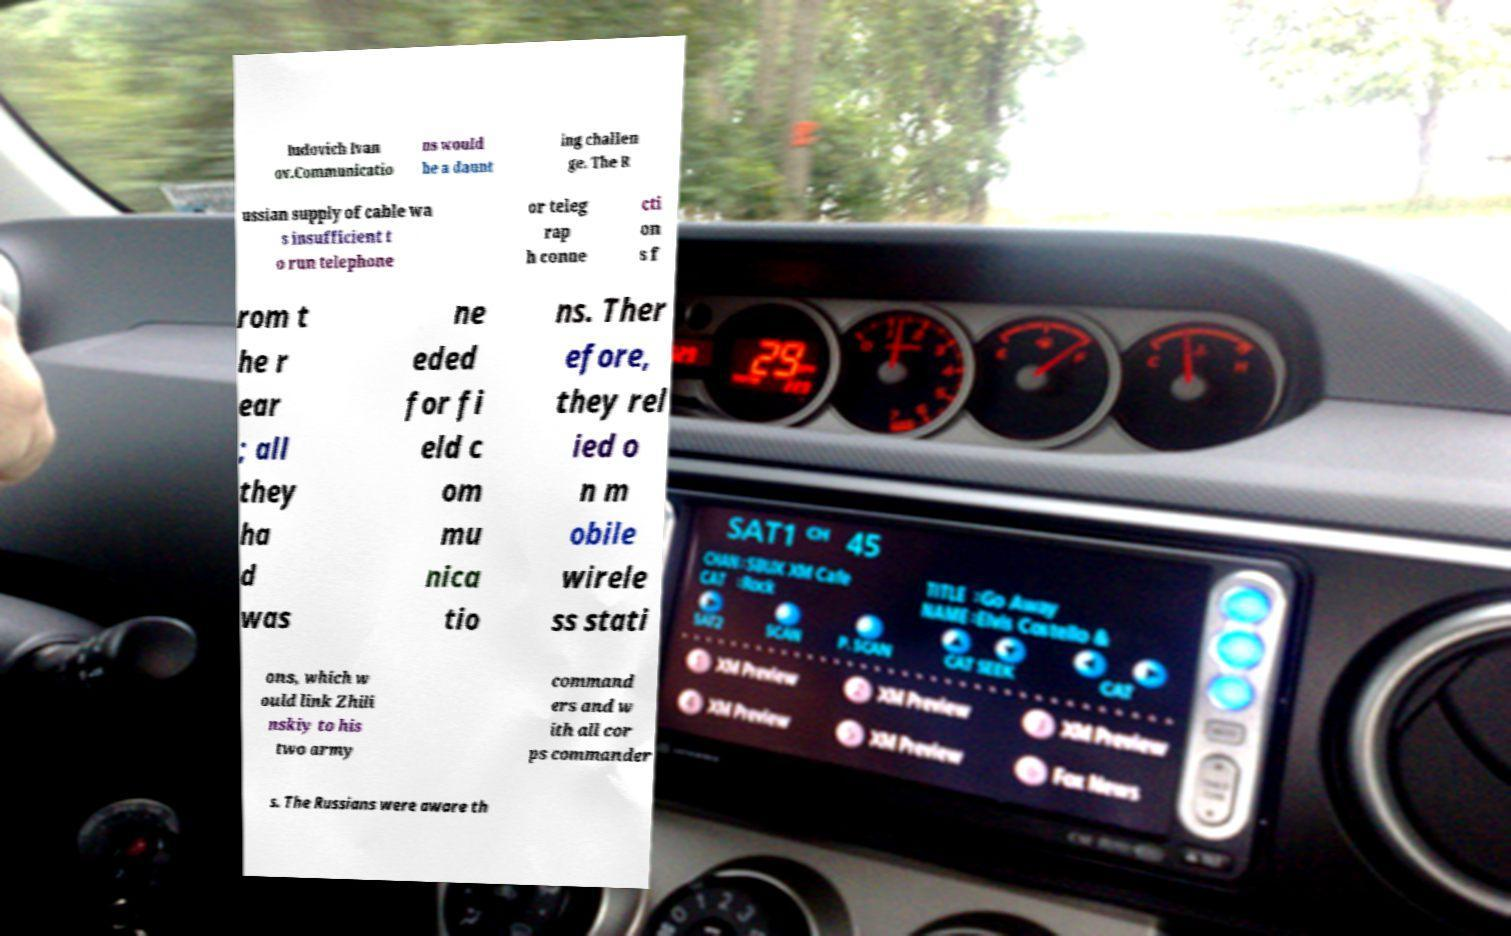Please identify and transcribe the text found in this image. Iudovich Ivan ov.Communicatio ns would be a daunt ing challen ge. The R ussian supply of cable wa s insufficient t o run telephone or teleg rap h conne cti on s f rom t he r ear ; all they ha d was ne eded for fi eld c om mu nica tio ns. Ther efore, they rel ied o n m obile wirele ss stati ons, which w ould link Zhili nskiy to his two army command ers and w ith all cor ps commander s. The Russians were aware th 